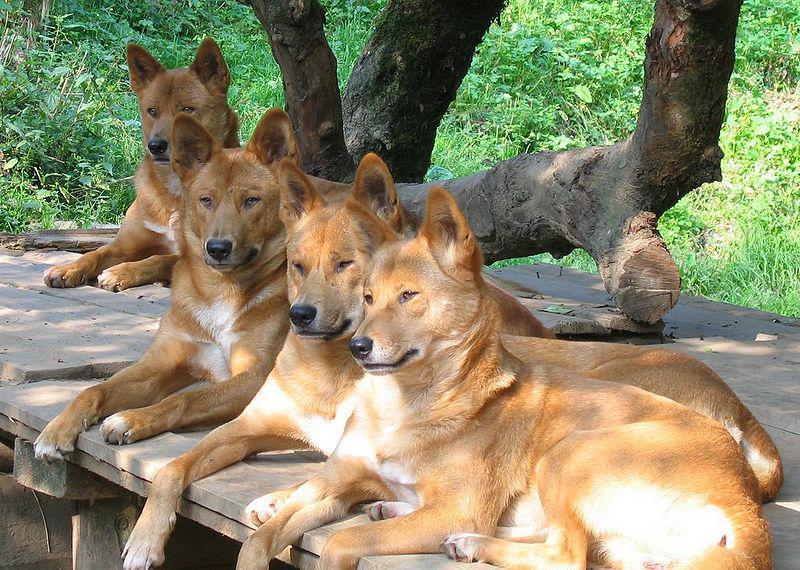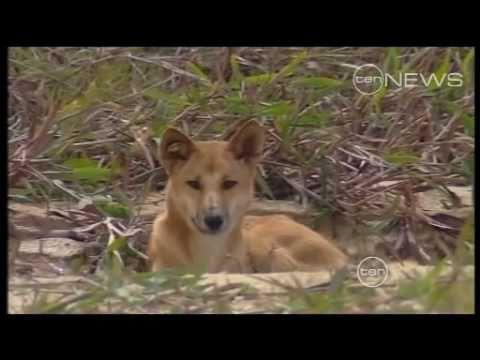The first image is the image on the left, the second image is the image on the right. Assess this claim about the two images: "There are two dogs total on both images.". Correct or not? Answer yes or no. No. 